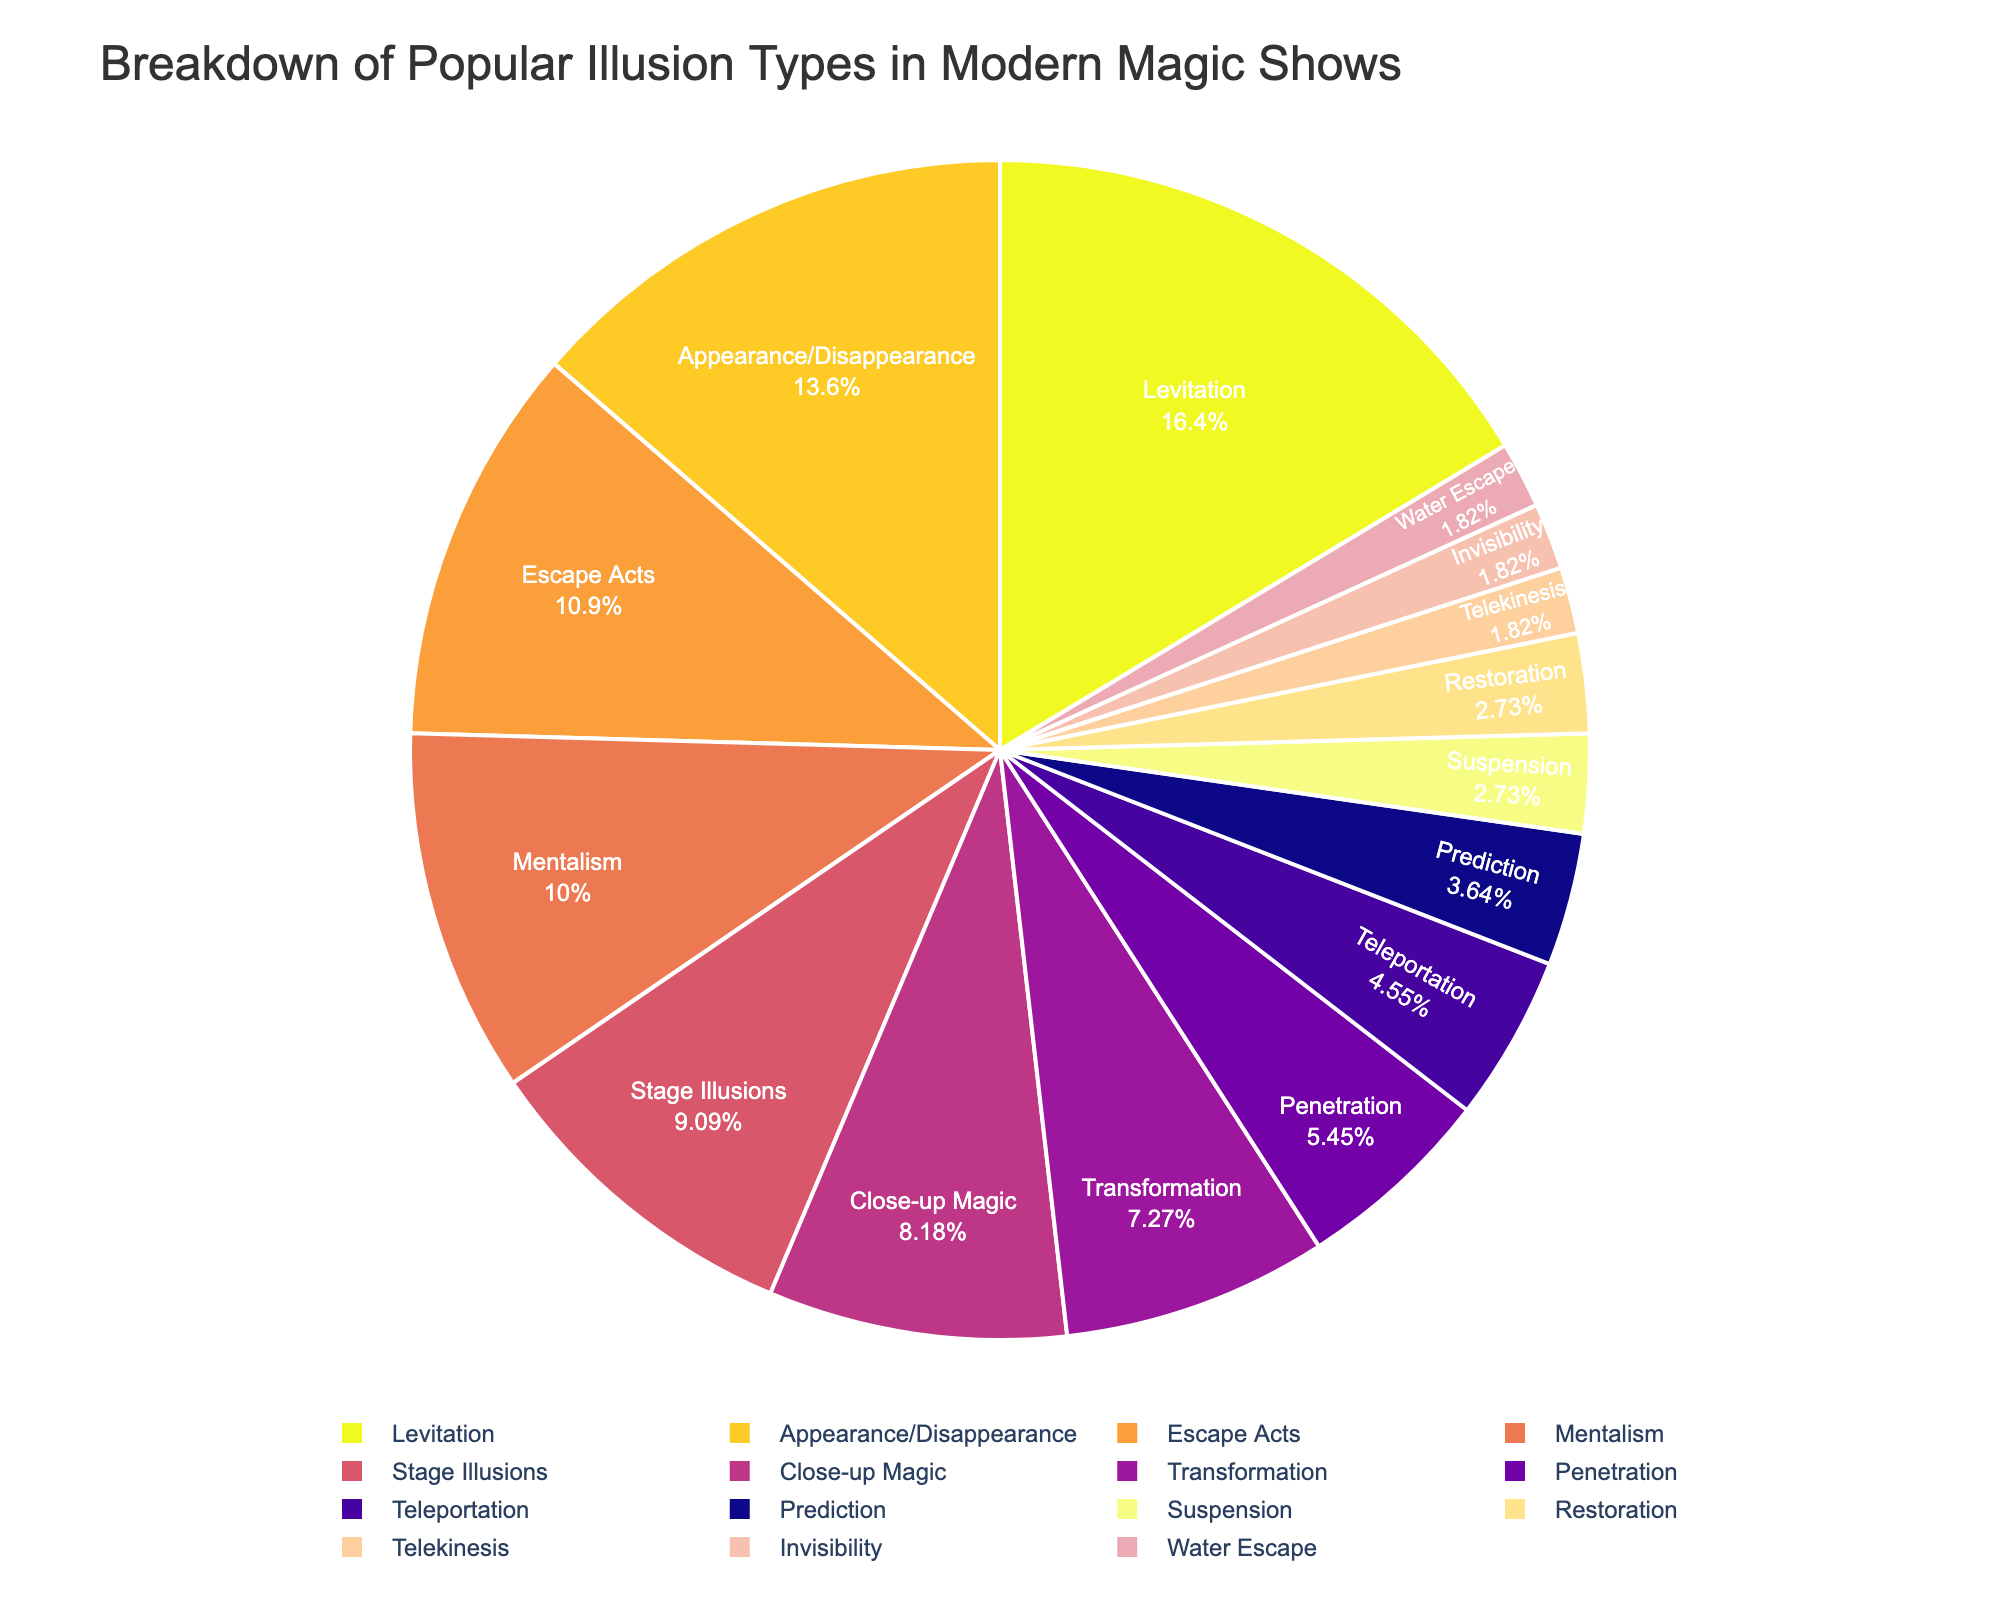What percentage of the pie chart is made up by Levitation, Appearance/Disappearance, and Escape Acts combined? First, identify the percentages for Levitation (18%), Appearance/Disappearance (15%), and Escape Acts (12%). Sum these percentages: 18 + 15 + 12 = 45%.
Answer: 45% Which type of illusion occupies the smallest portion of the pie chart? Look at the pie chart and identify the categories with the smallest percentage values which are Suspension, Restoration, Telekinesis, Invisibility, and Water Escape, each with 2% except Suspension and Restoration with 3%. Therefore the correct answer is Telekinesis and Invisibility
Answer: Telekinesis, Invisibility How does the percentage for Mentalism compare to that for Prediction? Identify the percentages for Mentalism (11%) and Prediction (4%). Subtract Prediction's percentage from Mentalism's: 11% - 4% = 7%. Therefore, Mentalism has a 7% higher representation than Prediction.
Answer: 7% higher Which type of illusion has a higher percentage: Stage Illusions or Close-up Magic? Stage Illusions have 10% and Close-up Magic has 9%. Since 10% > 9%, Stage Illusions have a higher percentage.
Answer: Stage Illusions What is the sum of the percentages for illusions that are 5% and below? Illusions that are 5% and below are Teleportation (5%), Prediction (4%), Suspension (3%), Restoration (3%), Telekinesis (2%), Invisibility (2%), and Water Escape (2%). Sum these percentages: 5 + 4 + 3 + 3 + 2 + 2 + 2 = 21%.
Answer: 21% Which illusion types are represented by colors closer to yellow on the color gradient? Identify the colors in the pie chart, typically shades closer to yellow in sequential color palettes such as Plasma_r correspond to higher values. Therefore, Levitation (18%), Appearance/Disappearance (15%), and Escape Acts (12%) are represented by colors closer to yellow.
Answer: Levitation, Appearance/Disappearance, Escape Acts Is Mentalism represented by a slice larger or smaller than Transformation? Mentalism has 11% and Transformation has 8%. Since 11% > 8%, Mentalism is represented by a larger slice.
Answer: Larger What is the average percentage for the top three most popular illusion types? The top three illusion types are Levitation (18%), Appearance/Disappearance (15%), and Escape Acts (12%). Calculate the average: (18 + 15 + 12) / 3 = 15%.
Answer: 15% How many illusion types have a percentage that is equal to or greater than 10%? Identify illusion types with at least 10%: Levitation (18%), Appearance/Disappearance (15%), Escape Acts (12%), Mentalism (11%), and Stage Illusions (10%). Count them: there are 5 types.
Answer: 5 